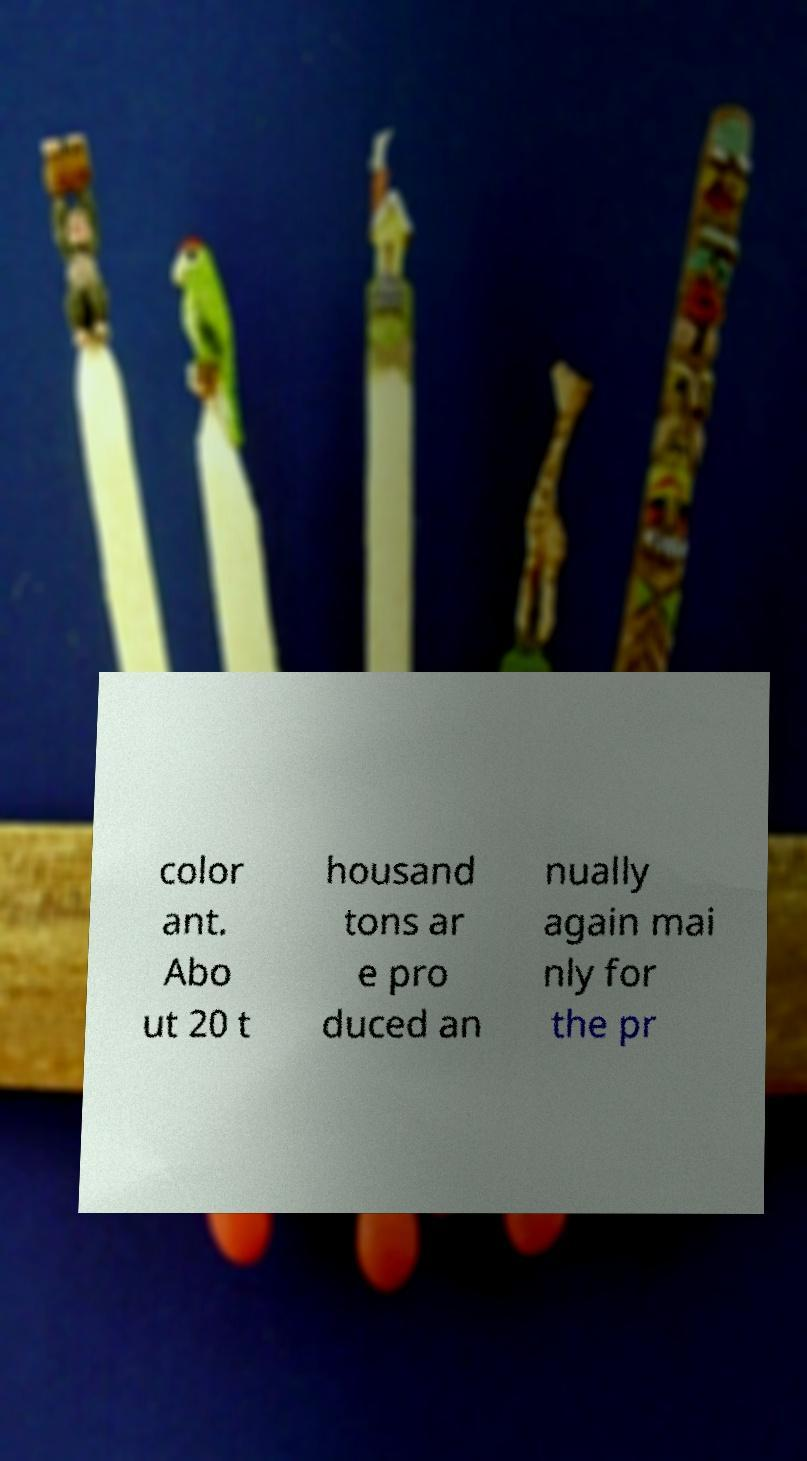Can you accurately transcribe the text from the provided image for me? color ant. Abo ut 20 t housand tons ar e pro duced an nually again mai nly for the pr 